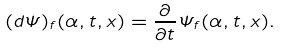Convert formula to latex. <formula><loc_0><loc_0><loc_500><loc_500>( d \Psi ) _ { f } ( \alpha , t , x ) = \frac { \partial } { \partial t } \Psi _ { f } ( \alpha , t , x ) .</formula> 